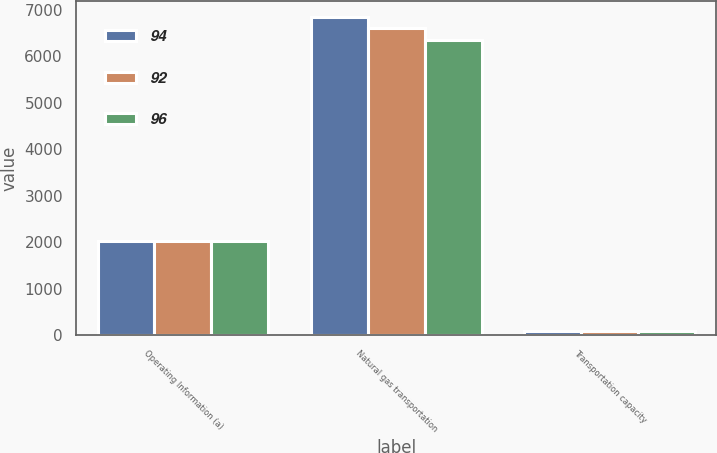Convert chart. <chart><loc_0><loc_0><loc_500><loc_500><stacked_bar_chart><ecel><fcel>Operating Information (a)<fcel>Natural gas transportation<fcel>Transportation capacity<nl><fcel>94<fcel>2018<fcel>6846<fcel>96<nl><fcel>92<fcel>2017<fcel>6611<fcel>94<nl><fcel>96<fcel>2016<fcel>6345<fcel>92<nl></chart> 